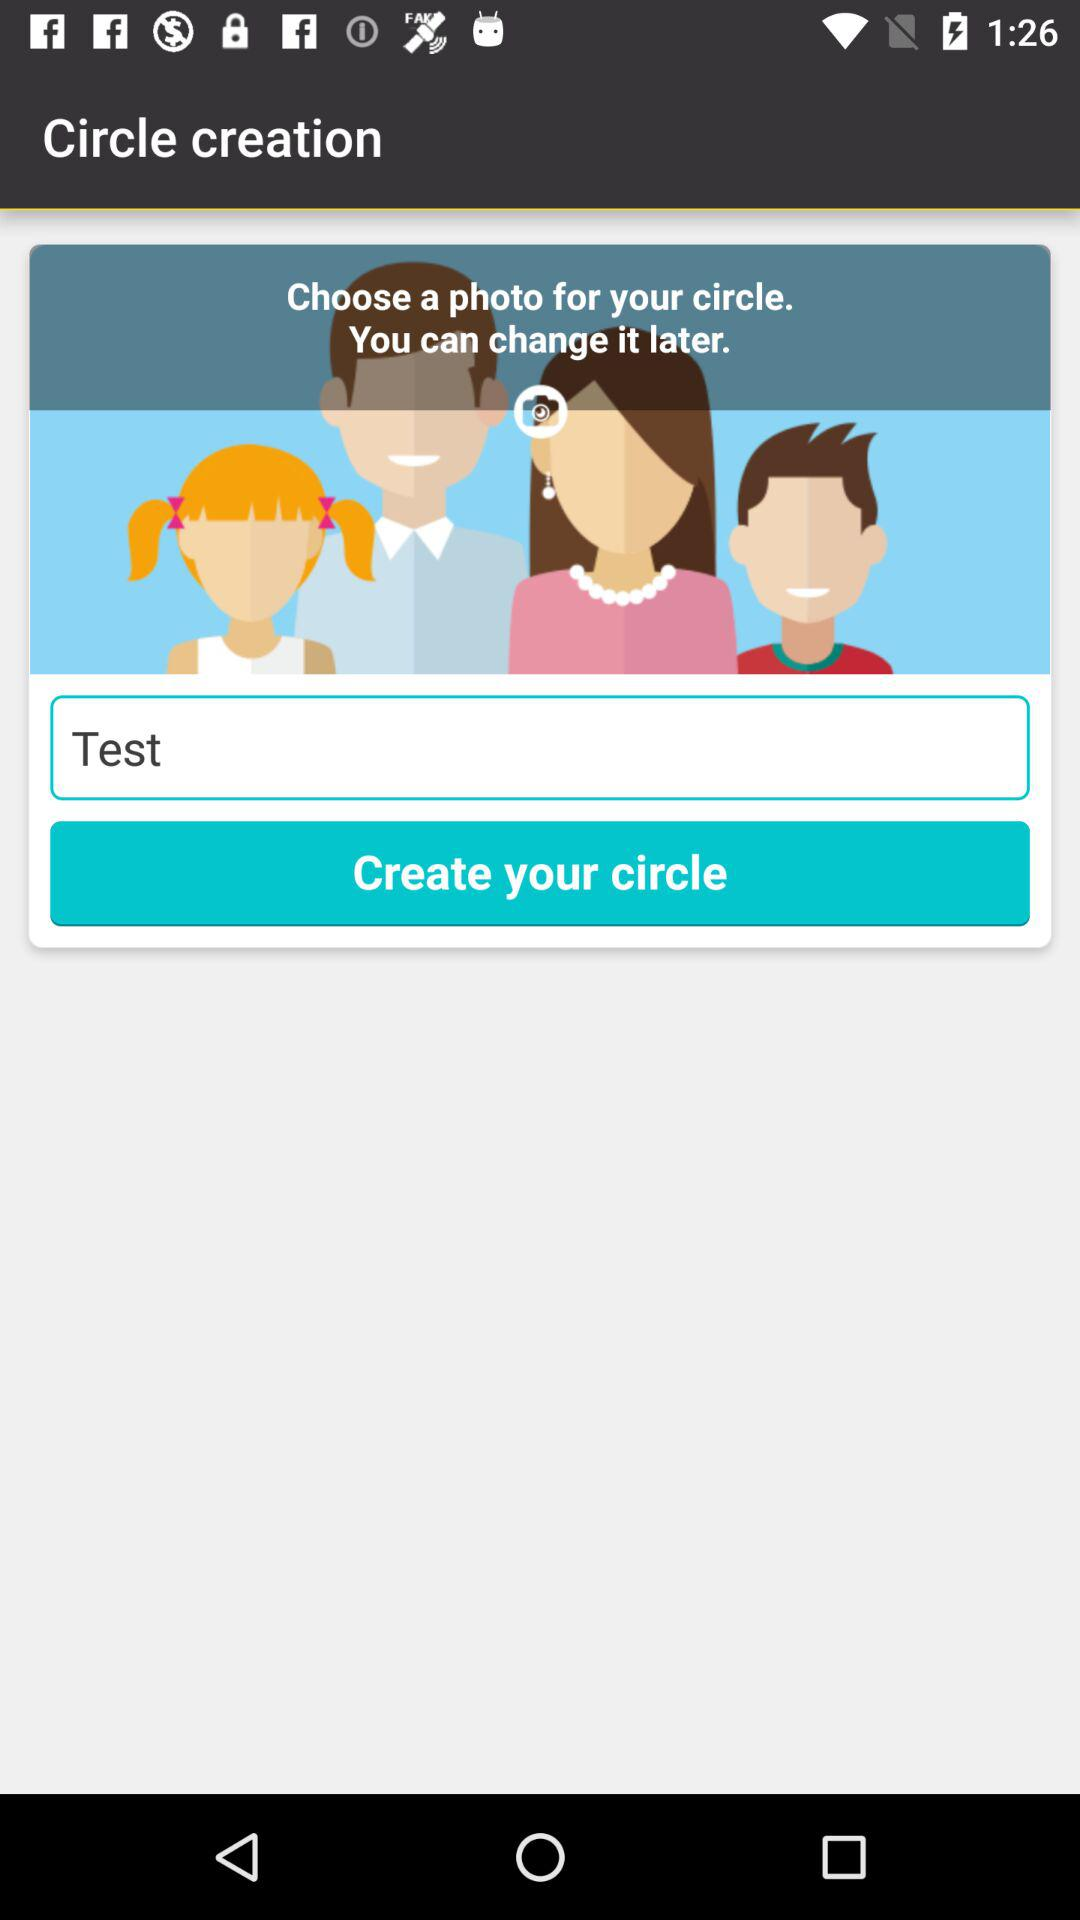What is the name of "Circle"? The name is "Test". 